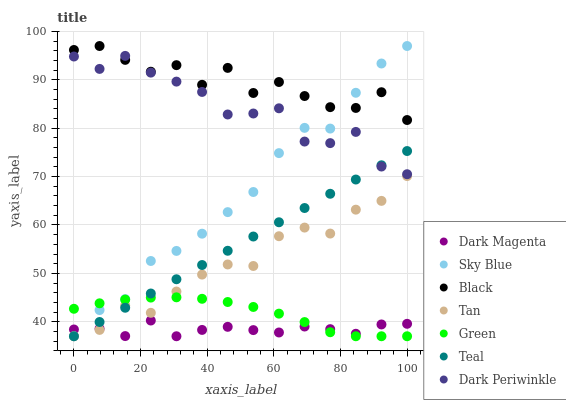Does Dark Magenta have the minimum area under the curve?
Answer yes or no. Yes. Does Black have the maximum area under the curve?
Answer yes or no. Yes. Does Green have the minimum area under the curve?
Answer yes or no. No. Does Green have the maximum area under the curve?
Answer yes or no. No. Is Teal the smoothest?
Answer yes or no. Yes. Is Black the roughest?
Answer yes or no. Yes. Is Dark Magenta the smoothest?
Answer yes or no. No. Is Dark Magenta the roughest?
Answer yes or no. No. Does Teal have the lowest value?
Answer yes or no. Yes. Does Black have the lowest value?
Answer yes or no. No. Does Sky Blue have the highest value?
Answer yes or no. Yes. Does Green have the highest value?
Answer yes or no. No. Is Dark Magenta less than Dark Periwinkle?
Answer yes or no. Yes. Is Black greater than Teal?
Answer yes or no. Yes. Does Dark Magenta intersect Sky Blue?
Answer yes or no. Yes. Is Dark Magenta less than Sky Blue?
Answer yes or no. No. Is Dark Magenta greater than Sky Blue?
Answer yes or no. No. Does Dark Magenta intersect Dark Periwinkle?
Answer yes or no. No. 